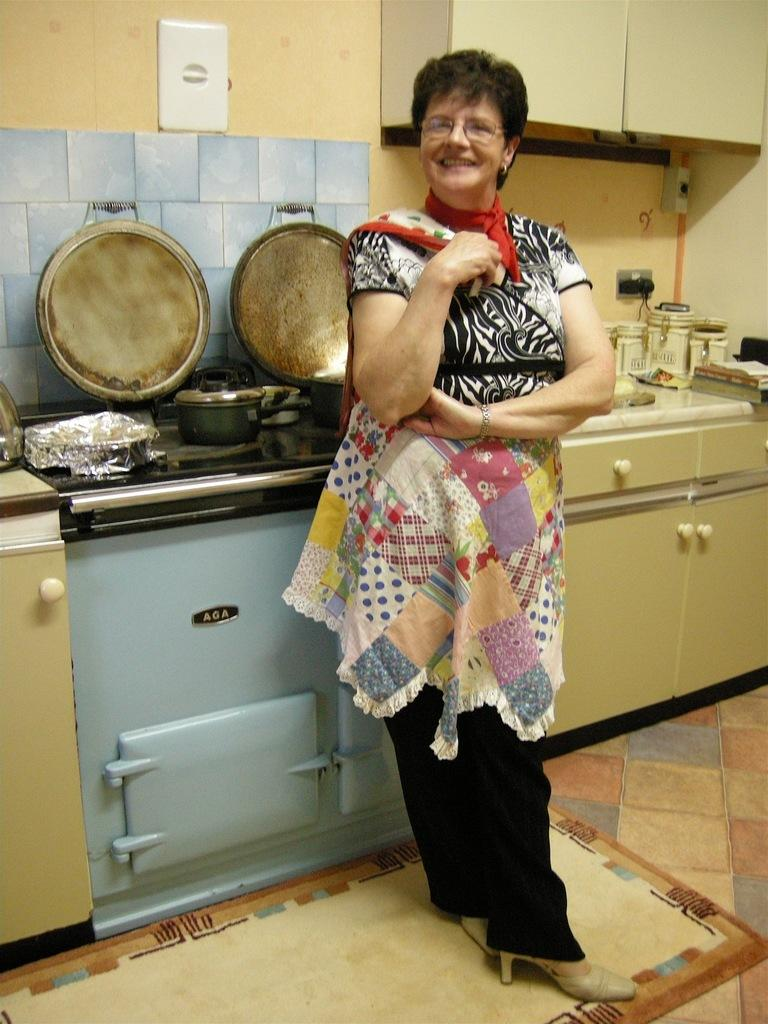<image>
Share a concise interpretation of the image provided. A smiling woman stands in front of an AGA stove. 